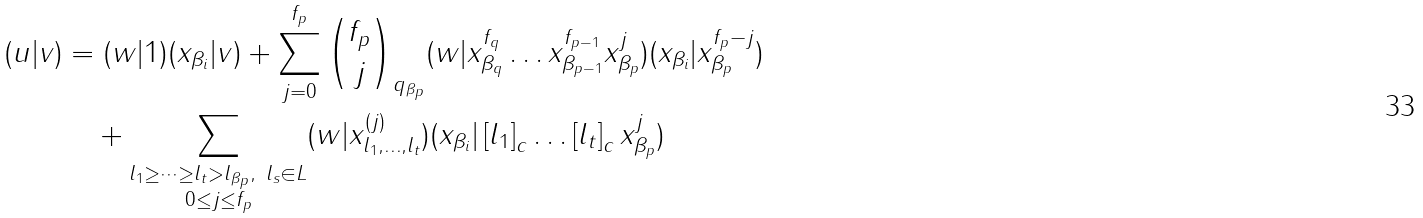Convert formula to latex. <formula><loc_0><loc_0><loc_500><loc_500>( u | v ) & = ( w | 1 ) ( x _ { \beta _ { i } } | v ) + \sum ^ { f _ { p } } _ { j = 0 } \binom { f _ { p } } { j } _ { q _ { \beta _ { p } } } ( w | x _ { \beta _ { q } } ^ { f _ { q } } \dots x _ { \beta _ { p - 1 } } ^ { f _ { p - 1 } } x _ { \beta _ { p } } ^ { j } ) ( x _ { \beta _ { i } } | x _ { \beta _ { p } } ^ { f _ { p } - j } ) \\ & \quad + \sum _ { \substack { l _ { 1 } \geq \dots \geq l _ { t } > l _ { \beta _ { p } } , \ l _ { s } \in L \\ 0 \leq j \leq f _ { p } } } ( w | x _ { l _ { 1 } , \dots , l _ { t } } ^ { ( j ) } ) ( x _ { \beta _ { i } } | \left [ l _ { 1 } \right ] _ { c } \dots \left [ l _ { t } \right ] _ { c } x _ { \beta _ { p } } ^ { j } )</formula> 